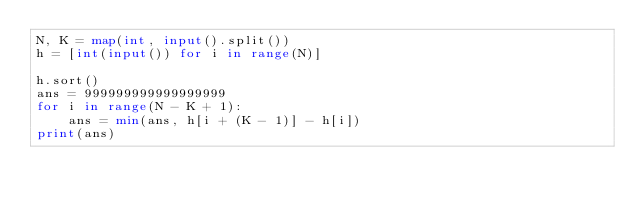<code> <loc_0><loc_0><loc_500><loc_500><_Python_>N, K = map(int, input().split())
h = [int(input()) for i in range(N)]

h.sort()
ans = 999999999999999999
for i in range(N - K + 1):
    ans = min(ans, h[i + (K - 1)] - h[i])
print(ans)</code> 